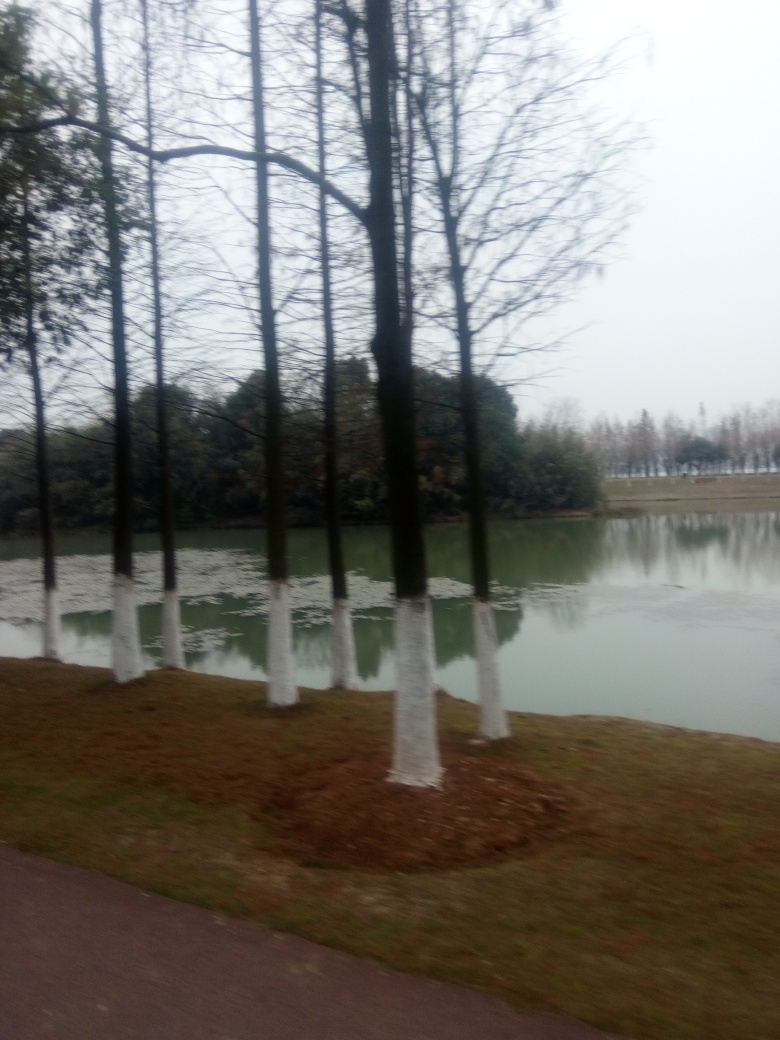Describe the setting of this image. The image depicts a row of trees with painted trunks alongside a body of water, which could be a lake or a river. The ground suggests recently done landscaping work, with brown mulch around the trees. The background is difficult to discern due to blurriness, but it seems to be a natural, possibly park-like setting. 